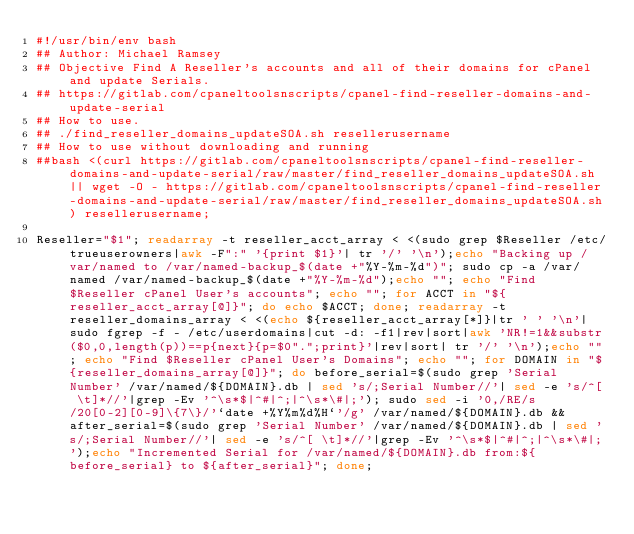<code> <loc_0><loc_0><loc_500><loc_500><_Bash_>#!/usr/bin/env bash
## Author: Michael Ramsey
## Objective Find A Reseller's accounts and all of their domains for cPanel and update Serials.
## https://gitlab.com/cpaneltoolsnscripts/cpanel-find-reseller-domains-and-update-serial
## How to use.
## ./find_reseller_domains_updateSOA.sh resellerusername
## How to use without downloading and running
##bash <(curl https://gitlab.com/cpaneltoolsnscripts/cpanel-find-reseller-domains-and-update-serial/raw/master/find_reseller_domains_updateSOA.sh || wget -O - https://gitlab.com/cpaneltoolsnscripts/cpanel-find-reseller-domains-and-update-serial/raw/master/find_reseller_domains_updateSOA.sh) resellerusername;

Reseller="$1"; readarray -t reseller_acct_array < <(sudo grep $Reseller /etc/trueuserowners|awk -F":" '{print $1}'| tr '/' '\n');echo "Backing up /var/named to /var/named-backup_$(date +"%Y-%m-%d")"; sudo cp -a /var/named /var/named-backup_$(date +"%Y-%m-%d");echo ""; echo "Find $Reseller cPanel User's accounts"; echo ""; for ACCT in "${reseller_acct_array[@]}"; do echo $ACCT; done; readarray -t reseller_domains_array < <(echo ${reseller_acct_array[*]}|tr ' ' '\n'|sudo fgrep -f - /etc/userdomains|cut -d: -f1|rev|sort|awk 'NR!=1&&substr($0,0,length(p))==p{next}{p=$0".";print}'|rev|sort| tr '/' '\n');echo ""; echo "Find $Reseller cPanel User's Domains"; echo ""; for DOMAIN in "${reseller_domains_array[@]}"; do before_serial=$(sudo grep 'Serial Number' /var/named/${DOMAIN}.db | sed 's/;Serial Number//'| sed -e 's/^[ \t]*//'|grep -Ev '^\s*$|^#|^;|^\s*\#|;'); sudo sed -i '0,/RE/s/20[0-2][0-9]\{7\}/'`date +%Y%m%d%H`'/g' /var/named/${DOMAIN}.db && after_serial=$(sudo grep 'Serial Number' /var/named/${DOMAIN}.db | sed 's/;Serial Number//'| sed -e 's/^[ \t]*//'|grep -Ev '^\s*$|^#|^;|^\s*\#|;');echo "Incremented Serial for /var/named/${DOMAIN}.db from:${before_serial} to ${after_serial}"; done;
</code> 